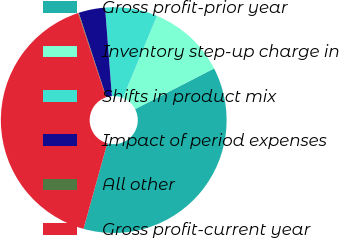Convert chart to OTSL. <chart><loc_0><loc_0><loc_500><loc_500><pie_chart><fcel>Gross profit-prior year<fcel>Inventory step-up charge in<fcel>Shifts in product mix<fcel>Impact of period expenses<fcel>All other<fcel>Gross profit-current year<nl><fcel>36.88%<fcel>11.17%<fcel>7.48%<fcel>3.79%<fcel>0.1%<fcel>40.57%<nl></chart> 